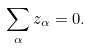<formula> <loc_0><loc_0><loc_500><loc_500>\sum _ { \alpha } z _ { \alpha } = 0 .</formula> 